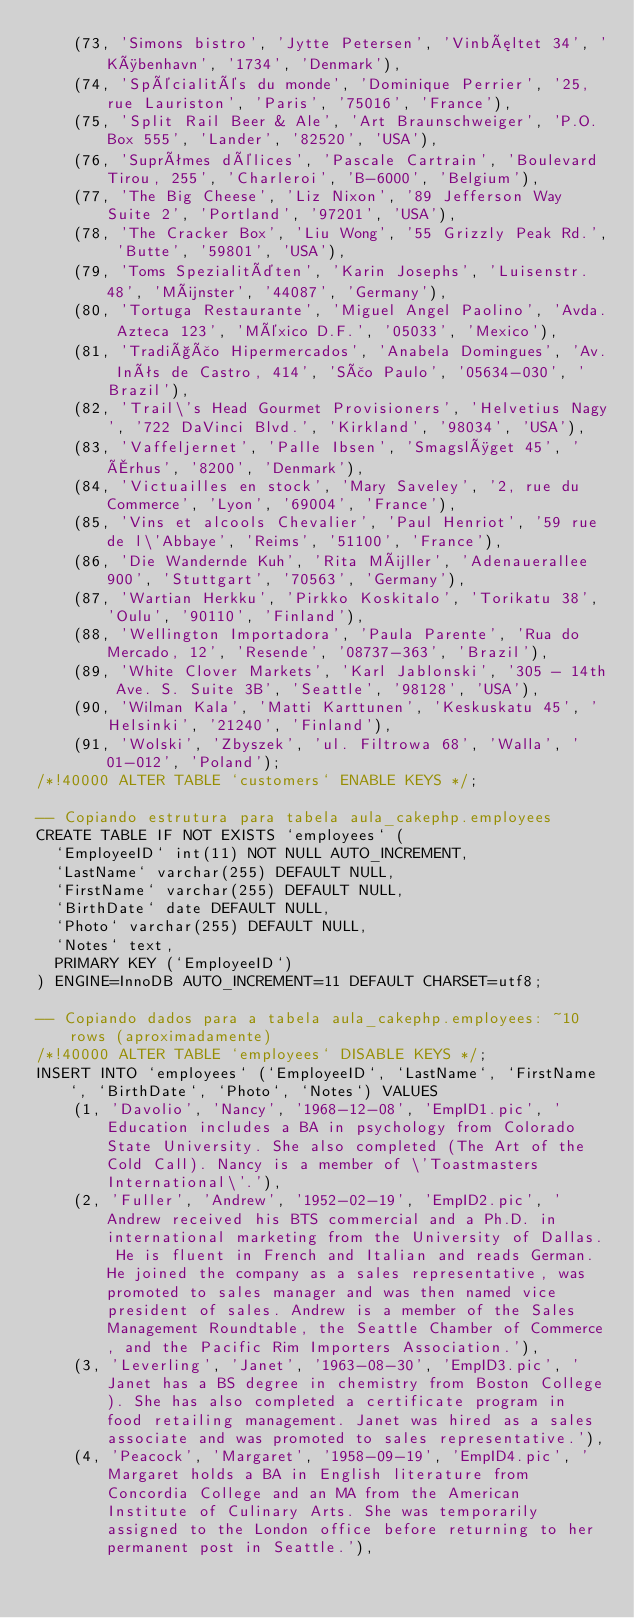Convert code to text. <code><loc_0><loc_0><loc_500><loc_500><_SQL_>	(73, 'Simons bistro', 'Jytte Petersen', 'Vinbæltet 34', 'København', '1734', 'Denmark'),
	(74, 'Spécialités du monde', 'Dominique Perrier', '25, rue Lauriston', 'Paris', '75016', 'France'),
	(75, 'Split Rail Beer & Ale', 'Art Braunschweiger', 'P.O. Box 555', 'Lander', '82520', 'USA'),
	(76, 'Suprêmes délices', 'Pascale Cartrain', 'Boulevard Tirou, 255', 'Charleroi', 'B-6000', 'Belgium'),
	(77, 'The Big Cheese', 'Liz Nixon', '89 Jefferson Way Suite 2', 'Portland', '97201', 'USA'),
	(78, 'The Cracker Box', 'Liu Wong', '55 Grizzly Peak Rd.', 'Butte', '59801', 'USA'),
	(79, 'Toms Spezialitäten', 'Karin Josephs', 'Luisenstr. 48', 'Münster', '44087', 'Germany'),
	(80, 'Tortuga Restaurante', 'Miguel Angel Paolino', 'Avda. Azteca 123', 'México D.F.', '05033', 'Mexico'),
	(81, 'Tradição Hipermercados', 'Anabela Domingues', 'Av. Inês de Castro, 414', 'São Paulo', '05634-030', 'Brazil'),
	(82, 'Trail\'s Head Gourmet Provisioners', 'Helvetius Nagy', '722 DaVinci Blvd.', 'Kirkland', '98034', 'USA'),
	(83, 'Vaffeljernet', 'Palle Ibsen', 'Smagsløget 45', 'Århus', '8200', 'Denmark'),
	(84, 'Victuailles en stock', 'Mary Saveley', '2, rue du Commerce', 'Lyon', '69004', 'France'),
	(85, 'Vins et alcools Chevalier', 'Paul Henriot', '59 rue de l\'Abbaye', 'Reims', '51100', 'France'),
	(86, 'Die Wandernde Kuh', 'Rita Müller', 'Adenauerallee 900', 'Stuttgart', '70563', 'Germany'),
	(87, 'Wartian Herkku', 'Pirkko Koskitalo', 'Torikatu 38', 'Oulu', '90110', 'Finland'),
	(88, 'Wellington Importadora', 'Paula Parente', 'Rua do Mercado, 12', 'Resende', '08737-363', 'Brazil'),
	(89, 'White Clover Markets', 'Karl Jablonski', '305 - 14th Ave. S. Suite 3B', 'Seattle', '98128', 'USA'),
	(90, 'Wilman Kala', 'Matti Karttunen', 'Keskuskatu 45', 'Helsinki', '21240', 'Finland'),
	(91, 'Wolski', 'Zbyszek', 'ul. Filtrowa 68', 'Walla', '01-012', 'Poland');
/*!40000 ALTER TABLE `customers` ENABLE KEYS */;

-- Copiando estrutura para tabela aula_cakephp.employees
CREATE TABLE IF NOT EXISTS `employees` (
  `EmployeeID` int(11) NOT NULL AUTO_INCREMENT,
  `LastName` varchar(255) DEFAULT NULL,
  `FirstName` varchar(255) DEFAULT NULL,
  `BirthDate` date DEFAULT NULL,
  `Photo` varchar(255) DEFAULT NULL,
  `Notes` text,
  PRIMARY KEY (`EmployeeID`)
) ENGINE=InnoDB AUTO_INCREMENT=11 DEFAULT CHARSET=utf8;

-- Copiando dados para a tabela aula_cakephp.employees: ~10 rows (aproximadamente)
/*!40000 ALTER TABLE `employees` DISABLE KEYS */;
INSERT INTO `employees` (`EmployeeID`, `LastName`, `FirstName`, `BirthDate`, `Photo`, `Notes`) VALUES
	(1, 'Davolio', 'Nancy', '1968-12-08', 'EmpID1.pic', 'Education includes a BA in psychology from Colorado State University. She also completed (The Art of the Cold Call). Nancy is a member of \'Toastmasters International\'.'),
	(2, 'Fuller', 'Andrew', '1952-02-19', 'EmpID2.pic', 'Andrew received his BTS commercial and a Ph.D. in international marketing from the University of Dallas. He is fluent in French and Italian and reads German. He joined the company as a sales representative, was promoted to sales manager and was then named vice president of sales. Andrew is a member of the Sales Management Roundtable, the Seattle Chamber of Commerce, and the Pacific Rim Importers Association.'),
	(3, 'Leverling', 'Janet', '1963-08-30', 'EmpID3.pic', 'Janet has a BS degree in chemistry from Boston College). She has also completed a certificate program in food retailing management. Janet was hired as a sales associate and was promoted to sales representative.'),
	(4, 'Peacock', 'Margaret', '1958-09-19', 'EmpID4.pic', 'Margaret holds a BA in English literature from Concordia College and an MA from the American Institute of Culinary Arts. She was temporarily assigned to the London office before returning to her permanent post in Seattle.'),</code> 